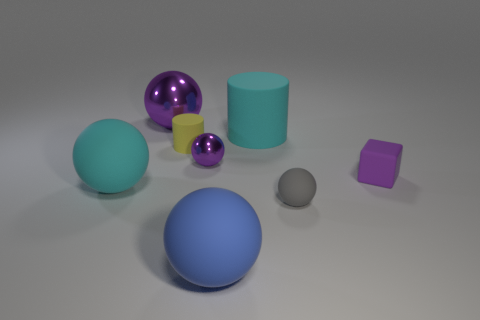Is the cylinder that is to the right of the tiny purple ball made of the same material as the yellow cylinder?
Provide a succinct answer. Yes. Are there an equal number of yellow cylinders that are to the right of the rubber block and big matte spheres that are to the left of the cyan ball?
Provide a succinct answer. Yes. There is a ball right of the big blue thing; what is its size?
Provide a succinct answer. Small. Are there any big cyan cylinders made of the same material as the purple cube?
Your answer should be compact. Yes. There is a metallic sphere that is in front of the tiny yellow rubber object; is it the same color as the large metal thing?
Your response must be concise. Yes. Are there an equal number of large cyan cylinders behind the big cylinder and big rubber cylinders?
Make the answer very short. No. Are there any small cylinders of the same color as the small metal thing?
Your answer should be very brief. No. Is the size of the cyan ball the same as the yellow object?
Ensure brevity in your answer.  No. What is the size of the ball in front of the small thing that is in front of the purple matte object?
Your answer should be compact. Large. There is a sphere that is on the right side of the large purple metallic ball and behind the tiny gray matte object; what size is it?
Keep it short and to the point. Small. 